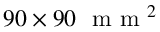Convert formula to latex. <formula><loc_0><loc_0><loc_500><loc_500>9 0 \times 9 0 m m ^ { 2 }</formula> 